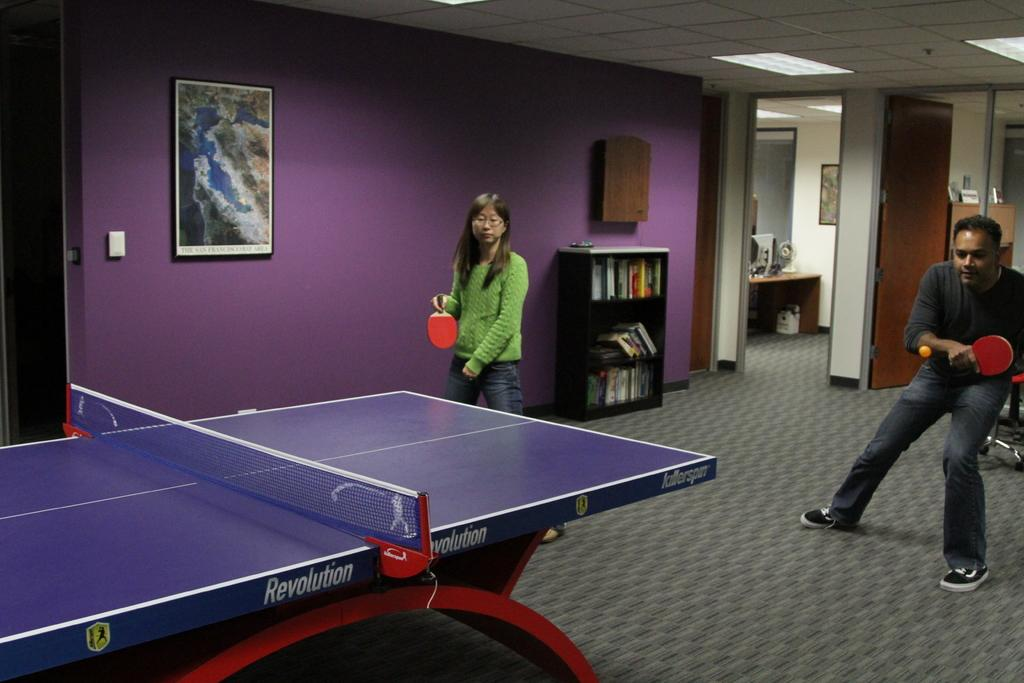What activity are the two people in the image engaged in? The two people in the image are playing table tennis. What can be seen on the wall in the image? There is a photo frame on the wall. What type of furniture is present in the image? There is a bookshelf in the image. How does the son react to his father's cough in the image? There is no son or father present in the image, nor is there any coughing. 